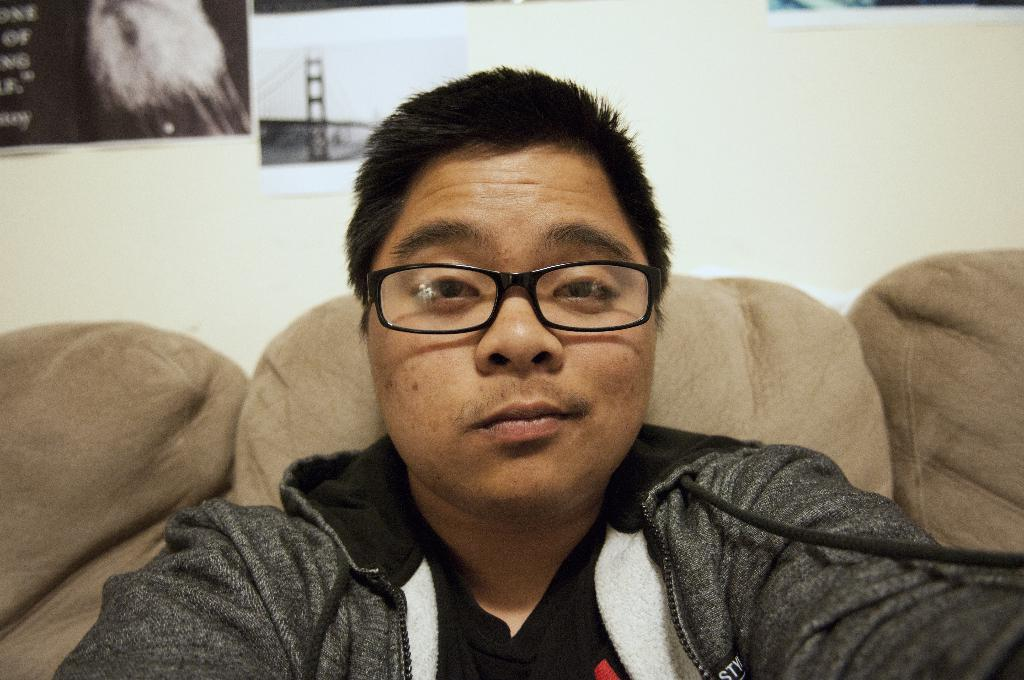Who is present in the image? There is a man in the image. What is the man wearing on his face? The man is wearing spectacles. What piece of furniture is in the image? There is a couch in the image. What can be seen in the background of the image? There is a wall in the background of the image. What is on the wall in the background? There are posters on the wall in the background. What type of cloud can be seen in the image? There are no clouds present in the image; it features a man, a couch, and posters on a wall. What key is used to unlock the man's spectacles in the image? There is no key mentioned or depicted in the image, and spectacles do not require keys to be worn. 